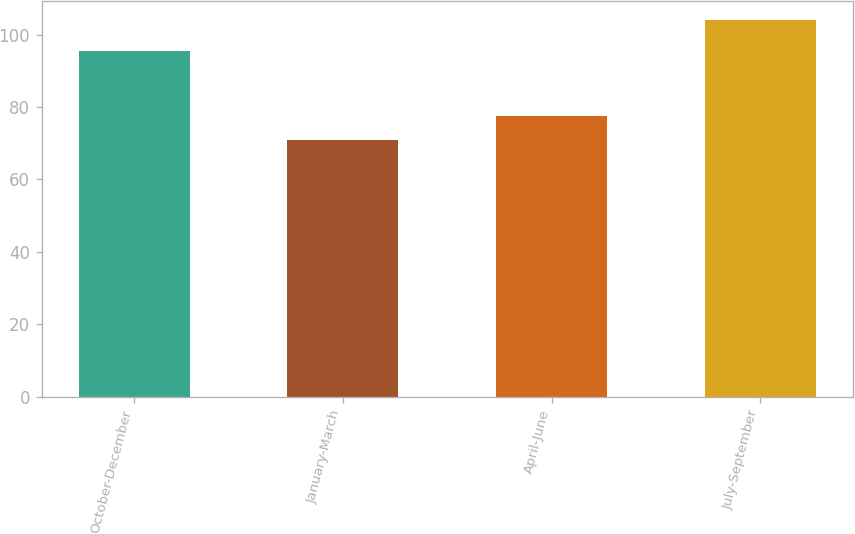Convert chart to OTSL. <chart><loc_0><loc_0><loc_500><loc_500><bar_chart><fcel>October-December<fcel>January-March<fcel>April-June<fcel>July-September<nl><fcel>95.49<fcel>70.82<fcel>77.62<fcel>104<nl></chart> 